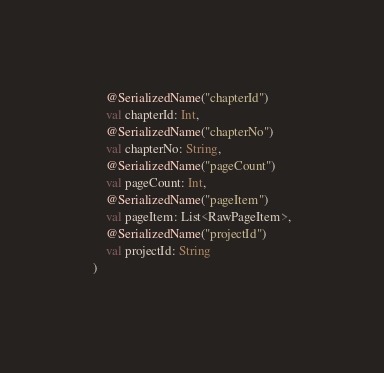<code> <loc_0><loc_0><loc_500><loc_500><_Kotlin_>    @SerializedName("chapterId")
    val chapterId: Int,
    @SerializedName("chapterNo")
    val chapterNo: String,
    @SerializedName("pageCount")
    val pageCount: Int,
    @SerializedName("pageItem")
    val pageItem: List<RawPageItem>,
    @SerializedName("projectId")
    val projectId: String
)
</code> 